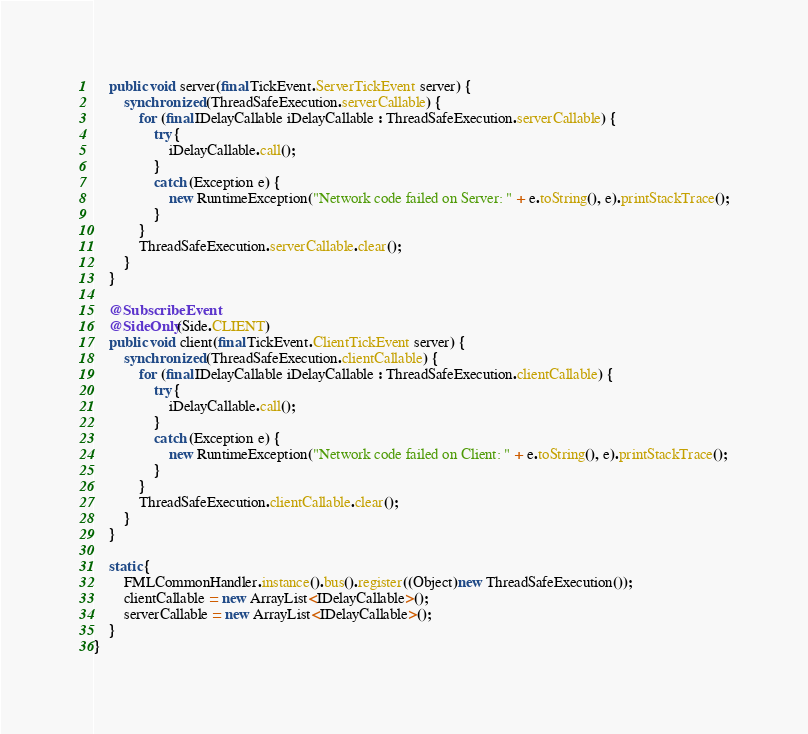<code> <loc_0><loc_0><loc_500><loc_500><_Java_>    public void server(final TickEvent.ServerTickEvent server) {
        synchronized (ThreadSafeExecution.serverCallable) {
            for (final IDelayCallable iDelayCallable : ThreadSafeExecution.serverCallable) {
                try {
                    iDelayCallable.call();
                }
                catch (Exception e) {
                    new RuntimeException("Network code failed on Server: " + e.toString(), e).printStackTrace();
                }
            }
            ThreadSafeExecution.serverCallable.clear();
        }
    }
    
    @SubscribeEvent
    @SideOnly(Side.CLIENT)
    public void client(final TickEvent.ClientTickEvent server) {
        synchronized (ThreadSafeExecution.clientCallable) {
            for (final IDelayCallable iDelayCallable : ThreadSafeExecution.clientCallable) {
                try {
                    iDelayCallable.call();
                }
                catch (Exception e) {
                    new RuntimeException("Network code failed on Client: " + e.toString(), e).printStackTrace();
                }
            }
            ThreadSafeExecution.clientCallable.clear();
        }
    }
    
    static {
        FMLCommonHandler.instance().bus().register((Object)new ThreadSafeExecution());
        clientCallable = new ArrayList<IDelayCallable>();
        serverCallable = new ArrayList<IDelayCallable>();
    }
}


</code> 